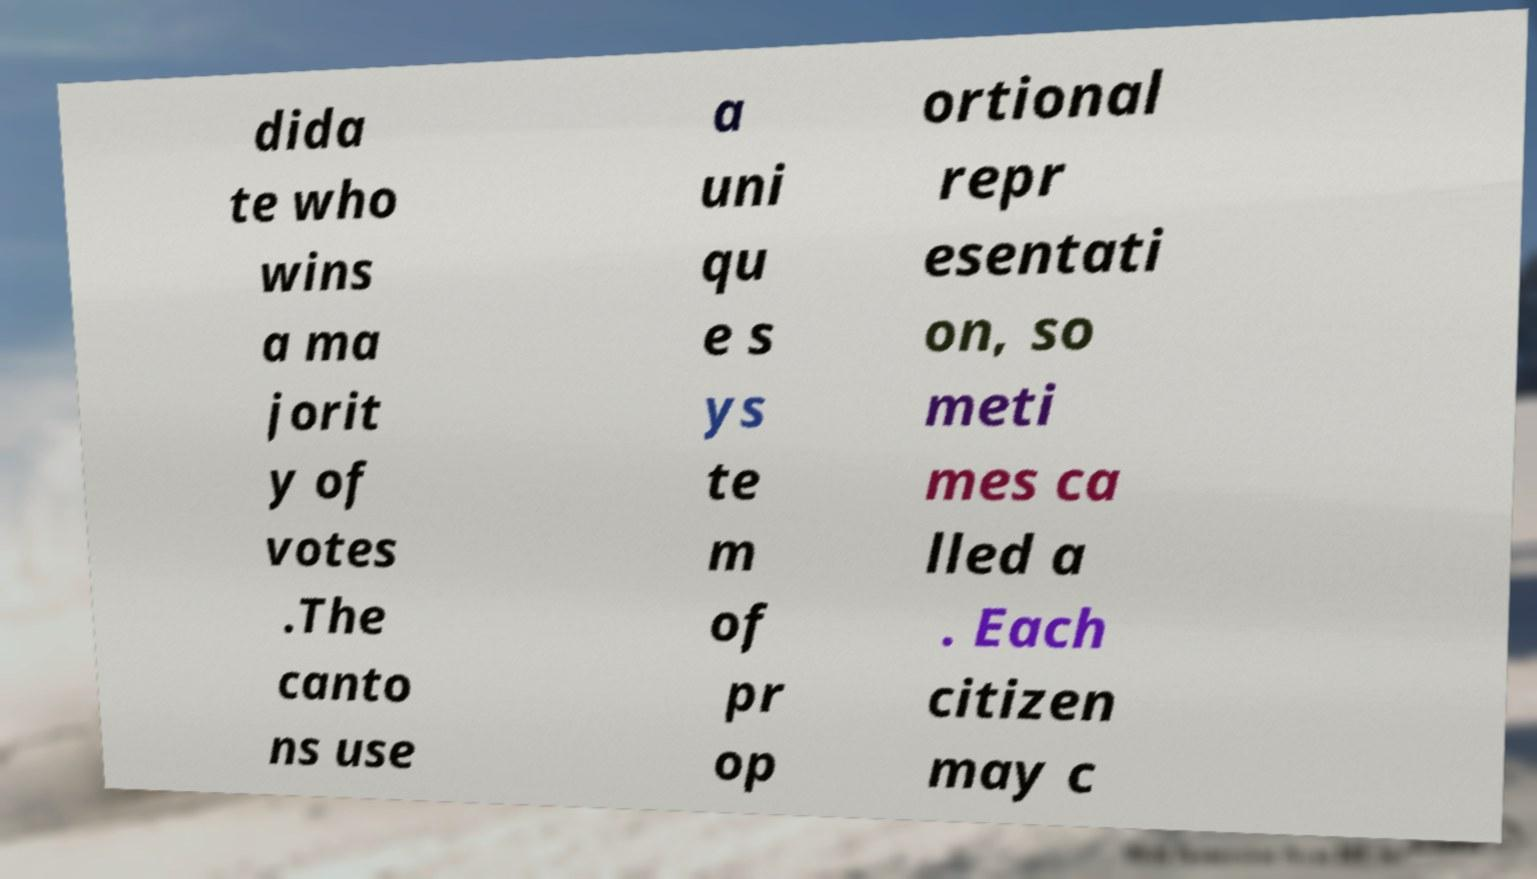There's text embedded in this image that I need extracted. Can you transcribe it verbatim? dida te who wins a ma jorit y of votes .The canto ns use a uni qu e s ys te m of pr op ortional repr esentati on, so meti mes ca lled a . Each citizen may c 